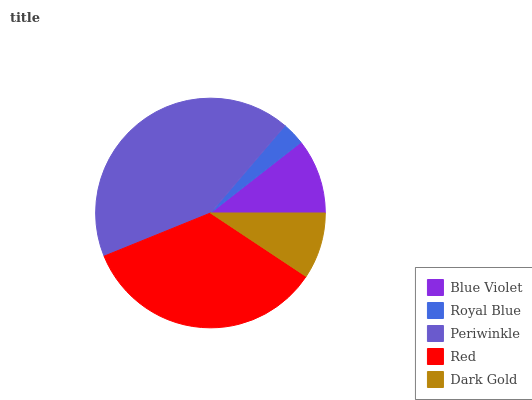Is Royal Blue the minimum?
Answer yes or no. Yes. Is Periwinkle the maximum?
Answer yes or no. Yes. Is Periwinkle the minimum?
Answer yes or no. No. Is Royal Blue the maximum?
Answer yes or no. No. Is Periwinkle greater than Royal Blue?
Answer yes or no. Yes. Is Royal Blue less than Periwinkle?
Answer yes or no. Yes. Is Royal Blue greater than Periwinkle?
Answer yes or no. No. Is Periwinkle less than Royal Blue?
Answer yes or no. No. Is Blue Violet the high median?
Answer yes or no. Yes. Is Blue Violet the low median?
Answer yes or no. Yes. Is Dark Gold the high median?
Answer yes or no. No. Is Red the low median?
Answer yes or no. No. 